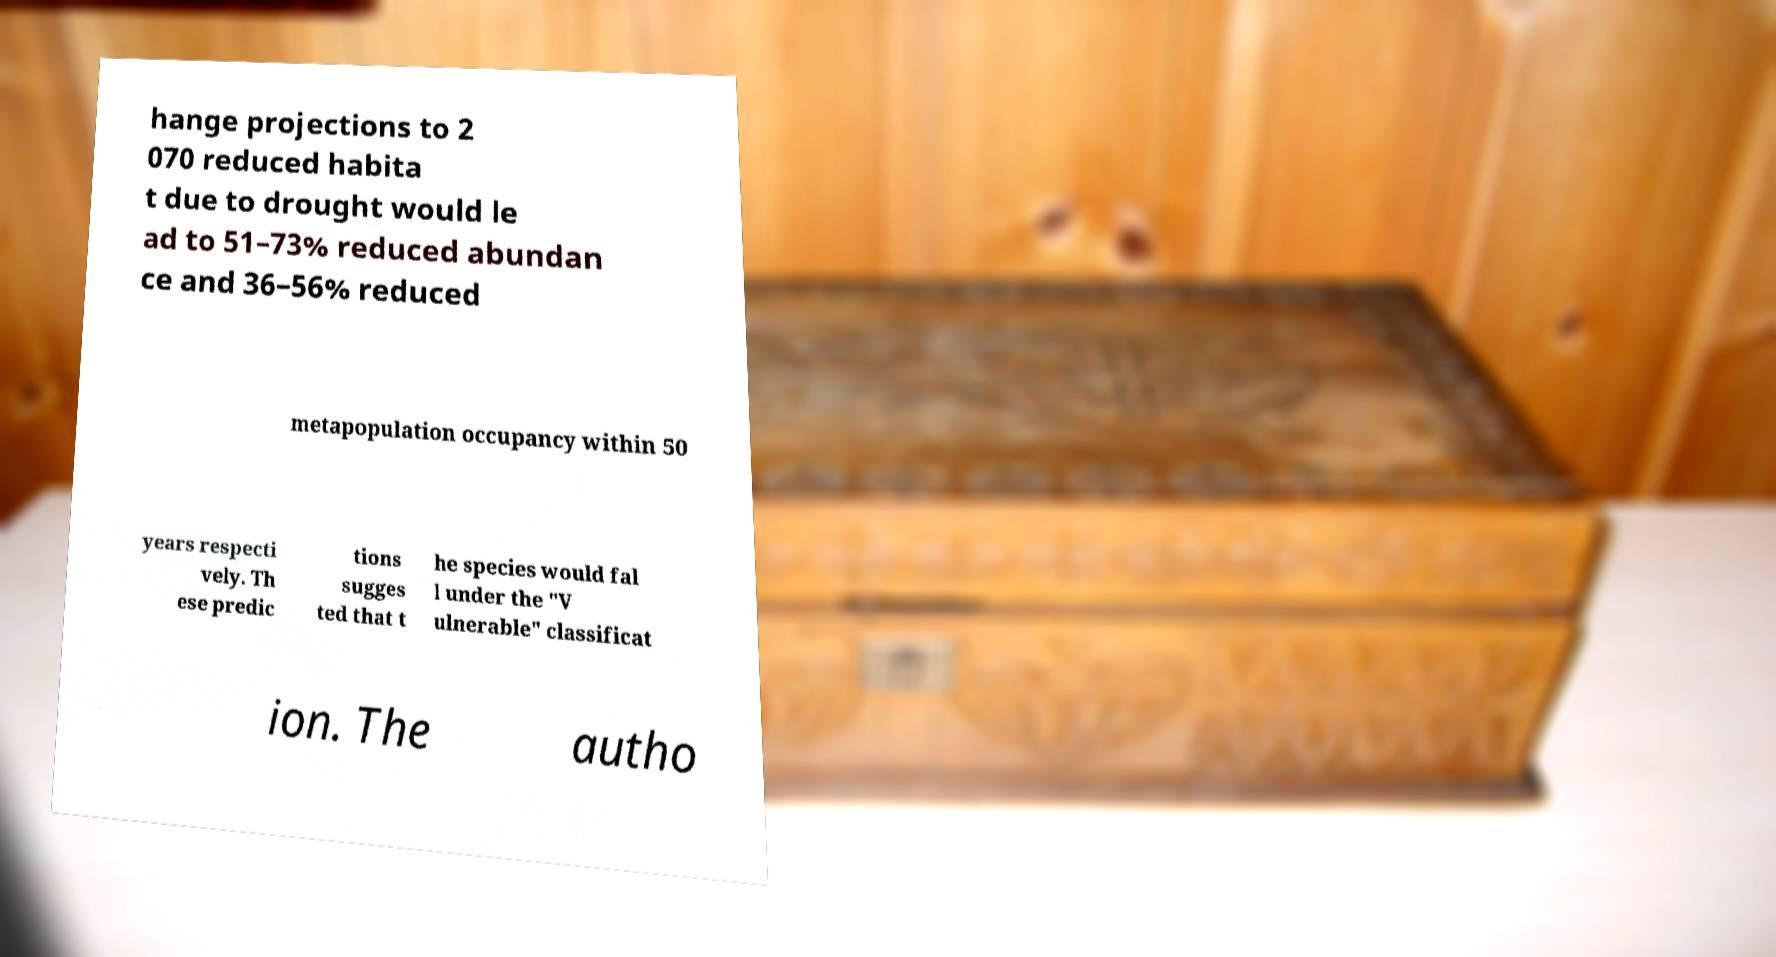What messages or text are displayed in this image? I need them in a readable, typed format. hange projections to 2 070 reduced habita t due to drought would le ad to 51–73% reduced abundan ce and 36–56% reduced metapopulation occupancy within 50 years respecti vely. Th ese predic tions sugges ted that t he species would fal l under the "V ulnerable" classificat ion. The autho 